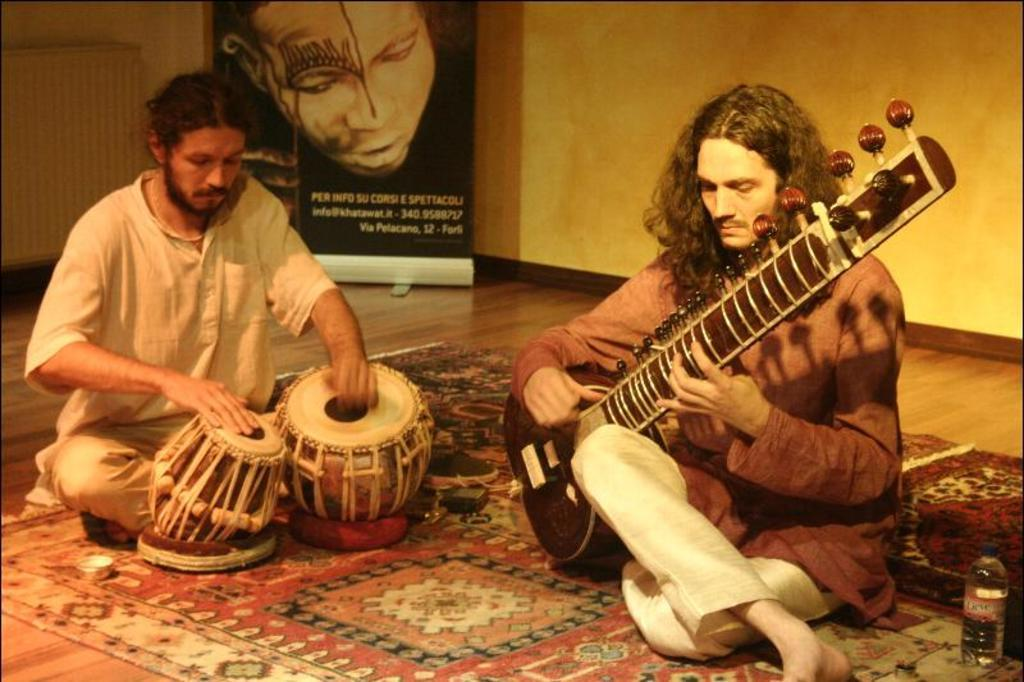How many people are in the image? There are two persons in the image. What are the persons doing in the image? The persons are sitting on a carpet and playing musical instruments. What else can be seen in the image besides the persons and their instruments? There is a banner and a bottle on the carpet. Is there a crook in the image trying to steal the musical instruments? No, there is no crook present in the image. Is it raining in the image? The provided facts do not mention any weather conditions, so we cannot determine if it is raining in the image. 